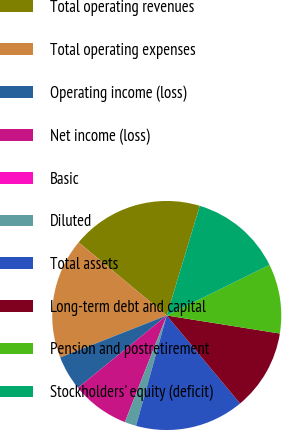<chart> <loc_0><loc_0><loc_500><loc_500><pie_chart><fcel>Total operating revenues<fcel>Total operating expenses<fcel>Operating income (loss)<fcel>Net income (loss)<fcel>Basic<fcel>Diluted<fcel>Total assets<fcel>Long-term debt and capital<fcel>Pension and postretirement<fcel>Stockholders' equity (deficit)<nl><fcel>18.63%<fcel>17.0%<fcel>4.9%<fcel>8.17%<fcel>0.0%<fcel>1.64%<fcel>15.37%<fcel>11.43%<fcel>9.8%<fcel>13.06%<nl></chart> 